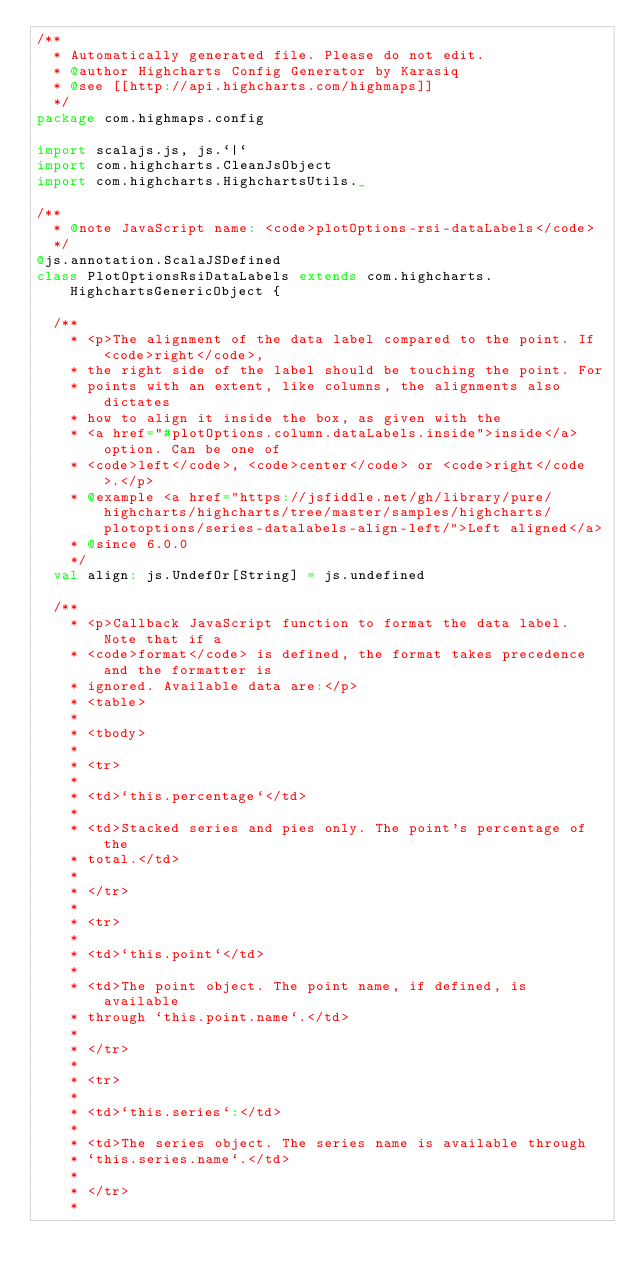Convert code to text. <code><loc_0><loc_0><loc_500><loc_500><_Scala_>/**
  * Automatically generated file. Please do not edit.
  * @author Highcharts Config Generator by Karasiq
  * @see [[http://api.highcharts.com/highmaps]]
  */
package com.highmaps.config

import scalajs.js, js.`|`
import com.highcharts.CleanJsObject
import com.highcharts.HighchartsUtils._

/**
  * @note JavaScript name: <code>plotOptions-rsi-dataLabels</code>
  */
@js.annotation.ScalaJSDefined
class PlotOptionsRsiDataLabels extends com.highcharts.HighchartsGenericObject {

  /**
    * <p>The alignment of the data label compared to the point. If <code>right</code>,
    * the right side of the label should be touching the point. For
    * points with an extent, like columns, the alignments also dictates
    * how to align it inside the box, as given with the
    * <a href="#plotOptions.column.dataLabels.inside">inside</a> option. Can be one of
    * <code>left</code>, <code>center</code> or <code>right</code>.</p>
    * @example <a href="https://jsfiddle.net/gh/library/pure/highcharts/highcharts/tree/master/samples/highcharts/plotoptions/series-datalabels-align-left/">Left aligned</a>
    * @since 6.0.0
    */
  val align: js.UndefOr[String] = js.undefined

  /**
    * <p>Callback JavaScript function to format the data label. Note that if a
    * <code>format</code> is defined, the format takes precedence and the formatter is
    * ignored. Available data are:</p>
    * <table>
    * 
    * <tbody>
    * 
    * <tr>
    * 
    * <td>`this.percentage`</td>
    * 
    * <td>Stacked series and pies only. The point's percentage of the
    * total.</td>
    * 
    * </tr>
    * 
    * <tr>
    * 
    * <td>`this.point`</td>
    * 
    * <td>The point object. The point name, if defined, is available
    * through `this.point.name`.</td>
    * 
    * </tr>
    * 
    * <tr>
    * 
    * <td>`this.series`:</td>
    * 
    * <td>The series object. The series name is available through
    * `this.series.name`.</td>
    * 
    * </tr>
    * </code> 